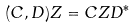<formula> <loc_0><loc_0><loc_500><loc_500>( C , D ) Z = C Z D ^ { * }</formula> 